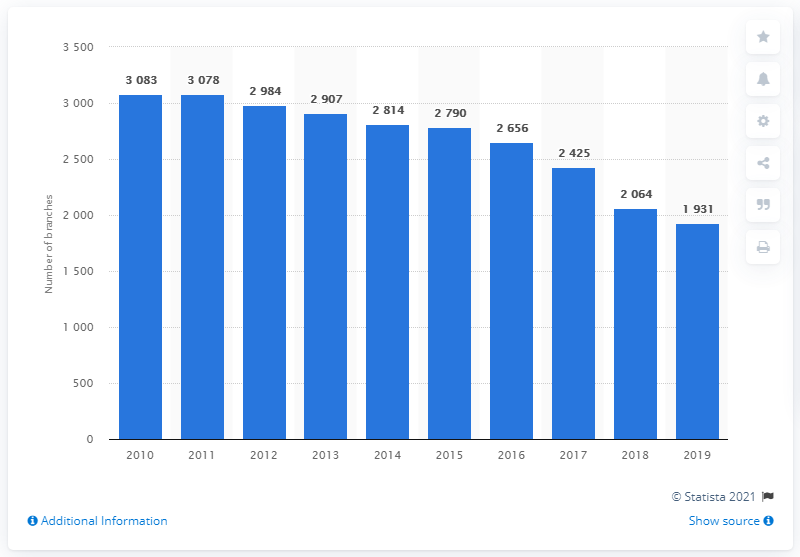List a handful of essential elements in this visual. In 2019, there were 1931 global Deutsche Bank branches. 